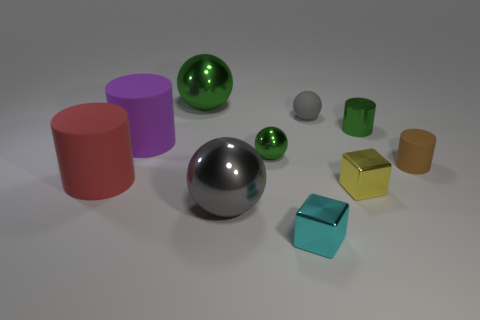Subtract 1 balls. How many balls are left? 3 Subtract all yellow cylinders. Subtract all red spheres. How many cylinders are left? 4 Subtract all cubes. How many objects are left? 8 Subtract all small red objects. Subtract all cyan metallic objects. How many objects are left? 9 Add 4 tiny gray rubber things. How many tiny gray rubber things are left? 5 Add 7 shiny blocks. How many shiny blocks exist? 9 Subtract 0 green blocks. How many objects are left? 10 